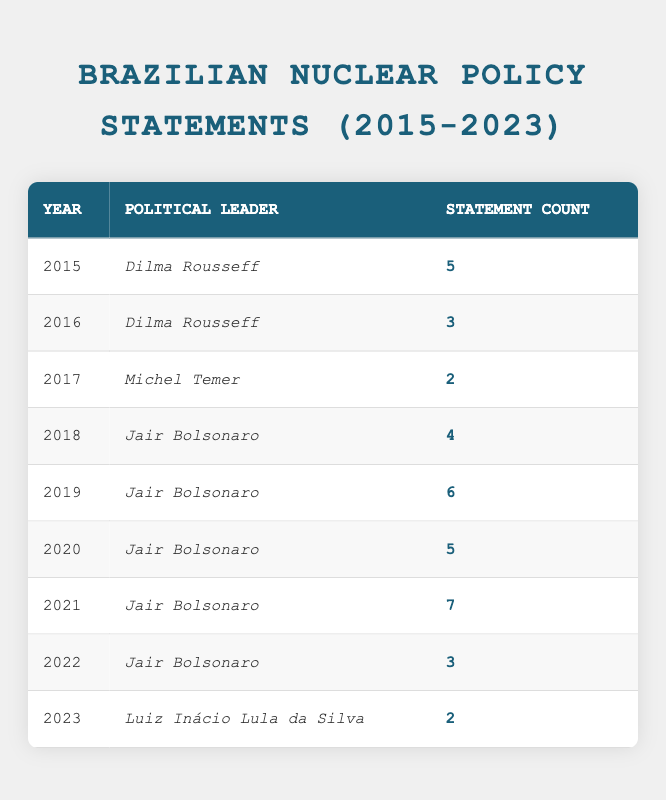What year saw the highest number of nuclear policy statements? By examining the statement counts for each year, we find that 2021 had the highest count with 7 statements made by Jair Bolsonaro.
Answer: 2021 How many statements did Dilma Rousseff make about nuclear policy in total? Adding up the statement counts for Dilma Rousseff from 2015 and 2016 gives us 5 + 3 = 8.
Answer: 8 In which year did Michel Temer make his nuclear policy statements? Michel Temer made statements in the year 2017, as indicated by the table.
Answer: 2017 Did Jair Bolsonaro make more nuclear policy statements in 2020 than in 2022? In 2020, Jair Bolsonaro made 5 statements, while in 2022 he made 3 statements. Since 5 > 3, the answer is yes.
Answer: Yes What is the average number of nuclear policy statements made by Jair Bolsonaro from 2018 to 2022? The statement counts from 2018 to 2022 are 4, 6, 5, 7, and 3 respectively. First, we sum them: 4 + 6 + 5 + 7 + 3 = 25. Next, we divide by 5 (the number of years) to find the average: 25 / 5 = 5.
Answer: 5 Which political leader had the least number of nuclear policy statements and how many did they make? Based on the table, Michel Temer has the least statement count with just 2 statements made in 2017.
Answer: Michel Temer, 2 Was the total number of nuclear policy statements made from 2015 to 2023 greater than 30? Adding all the statement counts: 5 + 3 + 2 + 4 + 6 + 5 + 7 + 3 + 2 = 37, which is greater than 30.
Answer: Yes How many statements were made in the year 2019 compared to the following year (2020)? In 2019, there were 6 statements, while in 2020 there were 5 statements. Since 6 > 5, we conclude that more statements were made in 2019 compared to 2020.
Answer: 2019 had more statements What trend can be observed in Jair Bolsonaro's nuclear policy statement counts from 2018 to 2021? The statement counts for Jair Bolsonaro during these years are: 4 (2018), 6 (2019), 5 (2020), and 7 (2021). The trend shows an increase from 2018 to 2019, a slight decrease in 2020, followed by an increase again in 2021.
Answer: Mixed trend with increase and decrease 